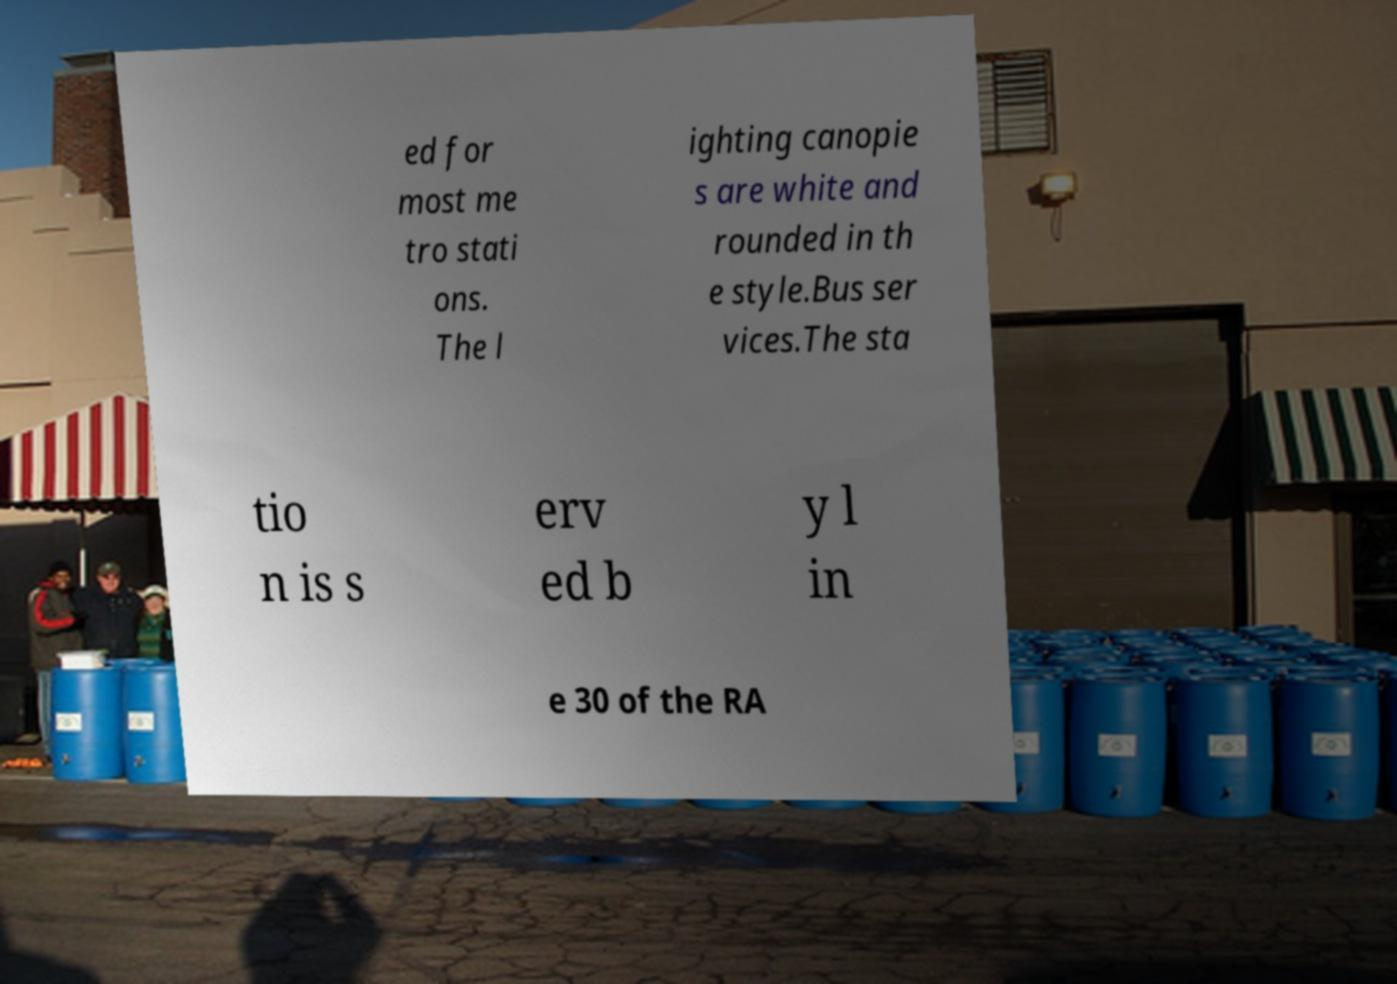There's text embedded in this image that I need extracted. Can you transcribe it verbatim? ed for most me tro stati ons. The l ighting canopie s are white and rounded in th e style.Bus ser vices.The sta tio n is s erv ed b y l in e 30 of the RA 